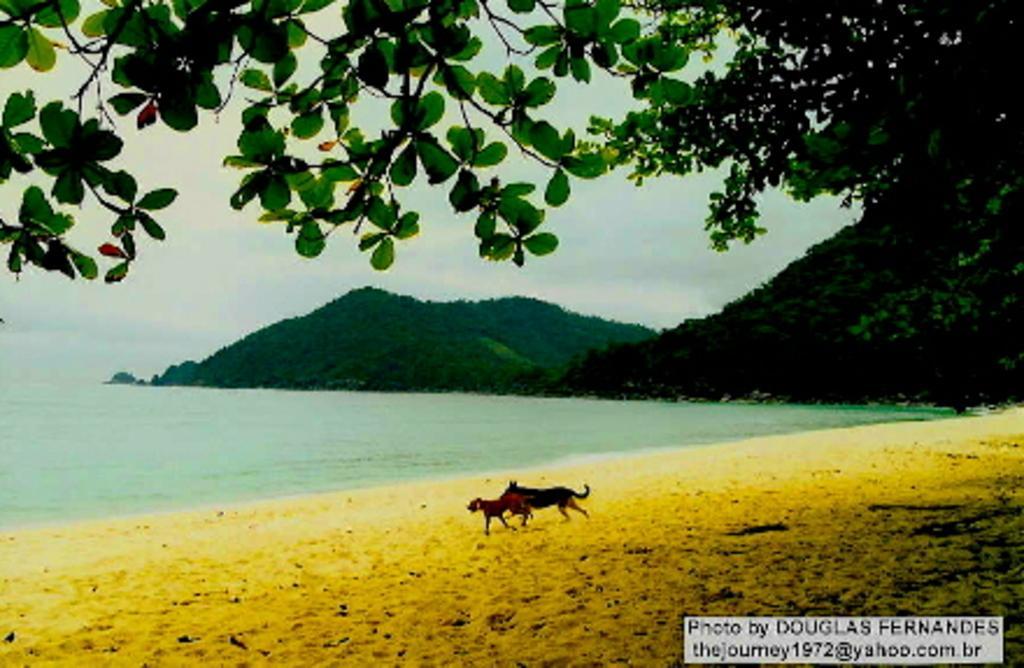Describe this image in one or two sentences. In this picture there are two dogs running on the beach. In the background I can see many trees on the mountain. On the left I can see the ocean. At the top I can see the sky and clouds. In the bottom right corner there is a watermark. 